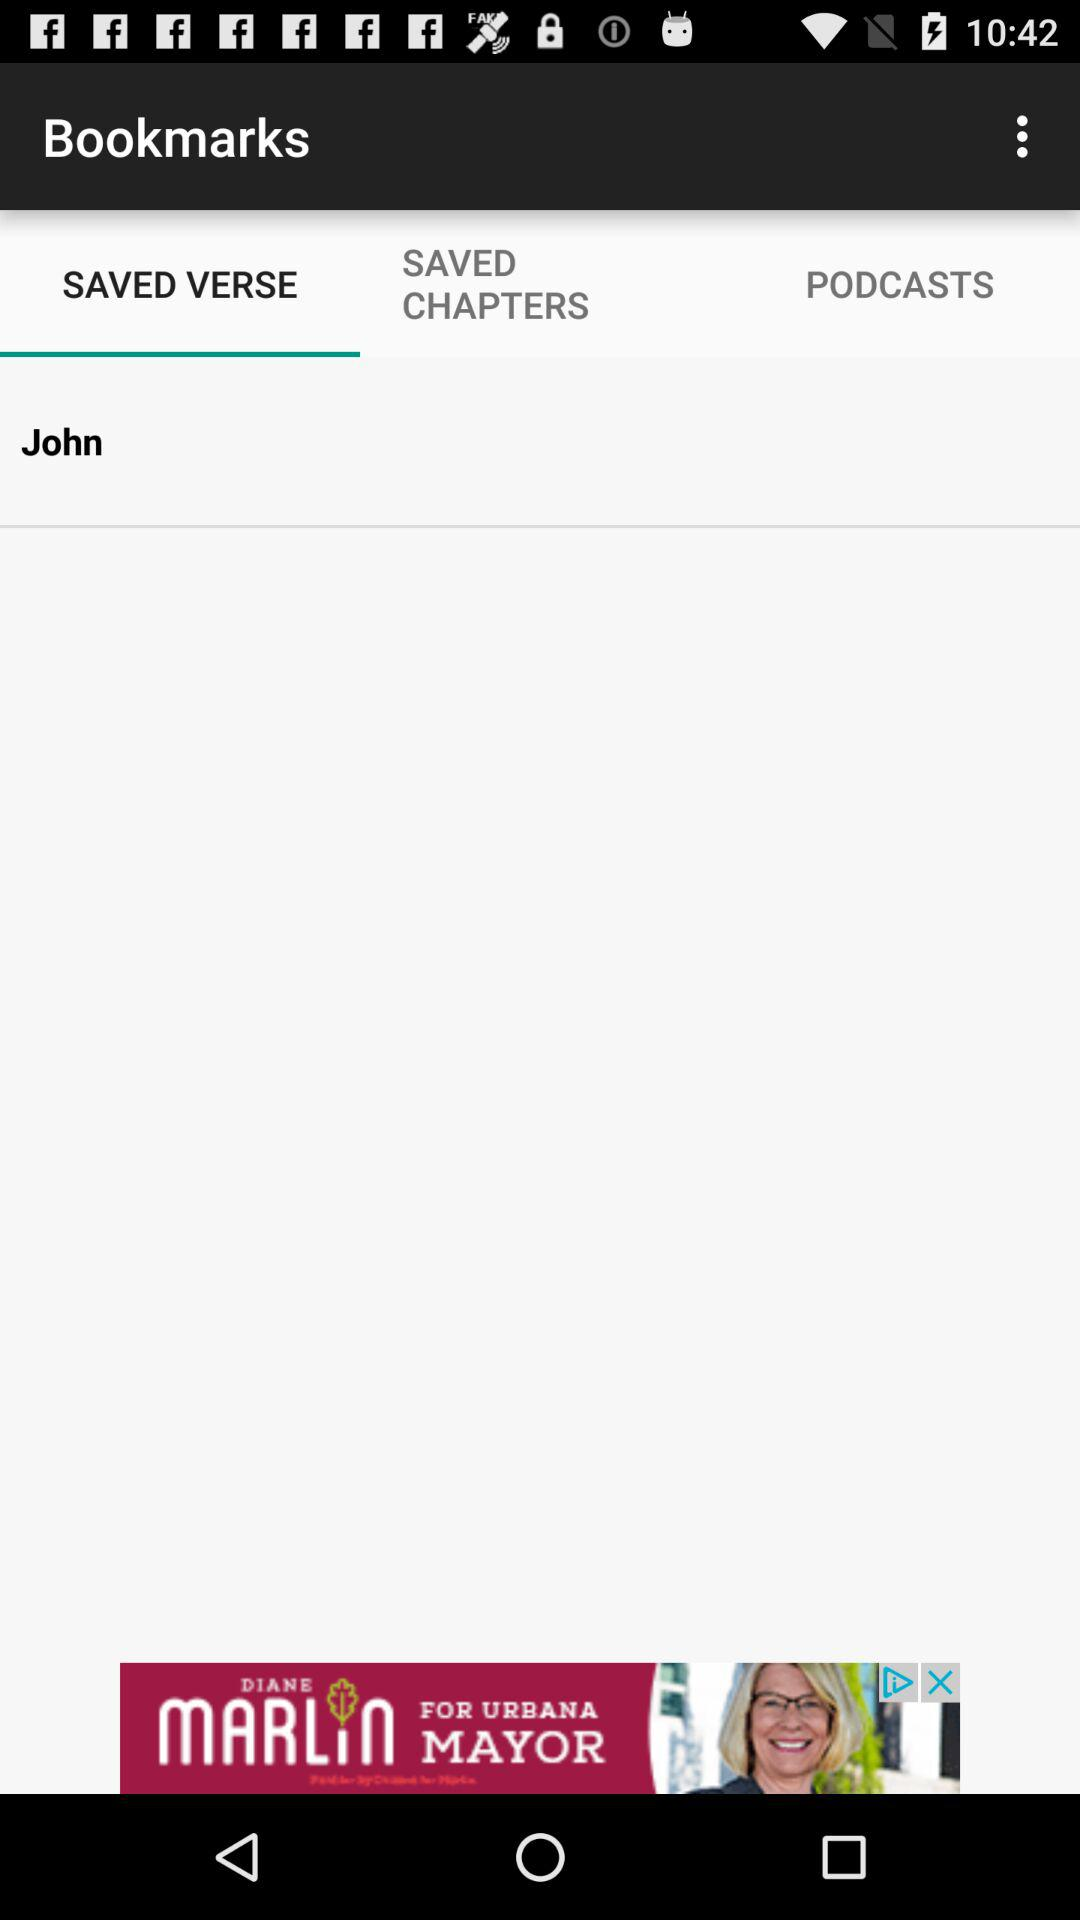What is the name of the user? The user name is "John". 